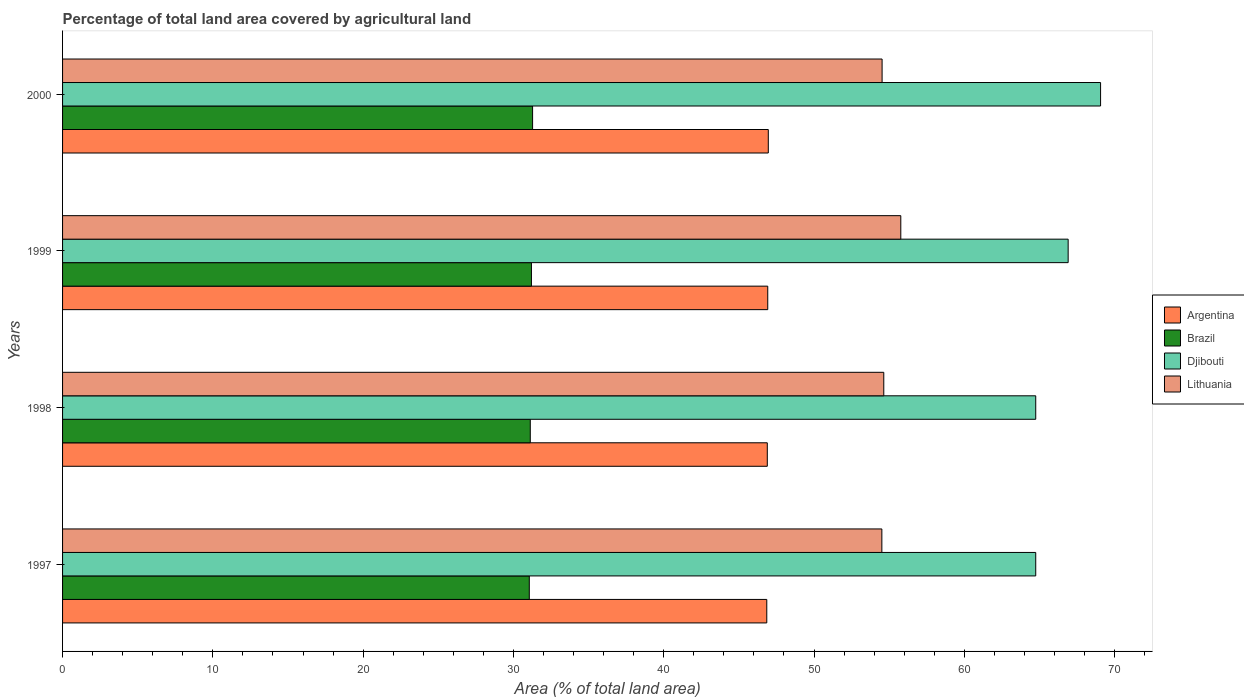How many different coloured bars are there?
Offer a terse response. 4. How many groups of bars are there?
Provide a short and direct response. 4. Are the number of bars on each tick of the Y-axis equal?
Give a very brief answer. Yes. How many bars are there on the 3rd tick from the top?
Provide a succinct answer. 4. How many bars are there on the 2nd tick from the bottom?
Provide a succinct answer. 4. What is the percentage of agricultural land in Lithuania in 1999?
Your answer should be very brief. 55.78. Across all years, what is the maximum percentage of agricultural land in Argentina?
Give a very brief answer. 46.96. Across all years, what is the minimum percentage of agricultural land in Lithuania?
Ensure brevity in your answer.  54.51. In which year was the percentage of agricultural land in Brazil minimum?
Keep it short and to the point. 1997. What is the total percentage of agricultural land in Djibouti in the graph?
Offer a very short reply. 265.49. What is the difference between the percentage of agricultural land in Argentina in 1997 and that in 1998?
Your response must be concise. -0.03. What is the difference between the percentage of agricultural land in Argentina in 2000 and the percentage of agricultural land in Brazil in 1999?
Give a very brief answer. 15.76. What is the average percentage of agricultural land in Djibouti per year?
Provide a short and direct response. 66.37. In the year 1999, what is the difference between the percentage of agricultural land in Argentina and percentage of agricultural land in Brazil?
Offer a very short reply. 15.72. In how many years, is the percentage of agricultural land in Djibouti greater than 44 %?
Keep it short and to the point. 4. What is the ratio of the percentage of agricultural land in Lithuania in 1997 to that in 2000?
Keep it short and to the point. 1. Is the percentage of agricultural land in Argentina in 1998 less than that in 2000?
Make the answer very short. Yes. What is the difference between the highest and the second highest percentage of agricultural land in Brazil?
Provide a succinct answer. 0.08. What is the difference between the highest and the lowest percentage of agricultural land in Brazil?
Provide a short and direct response. 0.22. Is the sum of the percentage of agricultural land in Djibouti in 1997 and 2000 greater than the maximum percentage of agricultural land in Argentina across all years?
Your answer should be compact. Yes. Is it the case that in every year, the sum of the percentage of agricultural land in Brazil and percentage of agricultural land in Djibouti is greater than the sum of percentage of agricultural land in Lithuania and percentage of agricultural land in Argentina?
Your answer should be very brief. Yes. What does the 2nd bar from the top in 2000 represents?
Your answer should be very brief. Djibouti. What does the 3rd bar from the bottom in 1998 represents?
Offer a very short reply. Djibouti. Is it the case that in every year, the sum of the percentage of agricultural land in Brazil and percentage of agricultural land in Argentina is greater than the percentage of agricultural land in Djibouti?
Offer a terse response. Yes. How many bars are there?
Provide a short and direct response. 16. How many years are there in the graph?
Provide a short and direct response. 4. Are the values on the major ticks of X-axis written in scientific E-notation?
Ensure brevity in your answer.  No. Does the graph contain any zero values?
Your answer should be compact. No. Does the graph contain grids?
Ensure brevity in your answer.  No. Where does the legend appear in the graph?
Your answer should be very brief. Center right. How many legend labels are there?
Offer a terse response. 4. How are the legend labels stacked?
Give a very brief answer. Vertical. What is the title of the graph?
Offer a very short reply. Percentage of total land area covered by agricultural land. Does "Virgin Islands" appear as one of the legend labels in the graph?
Ensure brevity in your answer.  No. What is the label or title of the X-axis?
Your answer should be very brief. Area (% of total land area). What is the Area (% of total land area) of Argentina in 1997?
Make the answer very short. 46.86. What is the Area (% of total land area) of Brazil in 1997?
Provide a succinct answer. 31.06. What is the Area (% of total land area) of Djibouti in 1997?
Your answer should be compact. 64.75. What is the Area (% of total land area) in Lithuania in 1997?
Provide a short and direct response. 54.51. What is the Area (% of total land area) in Argentina in 1998?
Your answer should be very brief. 46.89. What is the Area (% of total land area) in Brazil in 1998?
Your response must be concise. 31.12. What is the Area (% of total land area) of Djibouti in 1998?
Your answer should be compact. 64.75. What is the Area (% of total land area) in Lithuania in 1998?
Give a very brief answer. 54.64. What is the Area (% of total land area) in Argentina in 1999?
Provide a short and direct response. 46.92. What is the Area (% of total land area) of Brazil in 1999?
Give a very brief answer. 31.2. What is the Area (% of total land area) of Djibouti in 1999?
Ensure brevity in your answer.  66.91. What is the Area (% of total land area) in Lithuania in 1999?
Offer a terse response. 55.78. What is the Area (% of total land area) in Argentina in 2000?
Your response must be concise. 46.96. What is the Area (% of total land area) of Brazil in 2000?
Provide a succinct answer. 31.28. What is the Area (% of total land area) of Djibouti in 2000?
Ensure brevity in your answer.  69.07. What is the Area (% of total land area) in Lithuania in 2000?
Provide a succinct answer. 54.53. Across all years, what is the maximum Area (% of total land area) in Argentina?
Provide a succinct answer. 46.96. Across all years, what is the maximum Area (% of total land area) in Brazil?
Give a very brief answer. 31.28. Across all years, what is the maximum Area (% of total land area) in Djibouti?
Give a very brief answer. 69.07. Across all years, what is the maximum Area (% of total land area) of Lithuania?
Provide a short and direct response. 55.78. Across all years, what is the minimum Area (% of total land area) of Argentina?
Your answer should be compact. 46.86. Across all years, what is the minimum Area (% of total land area) of Brazil?
Keep it short and to the point. 31.06. Across all years, what is the minimum Area (% of total land area) in Djibouti?
Ensure brevity in your answer.  64.75. Across all years, what is the minimum Area (% of total land area) of Lithuania?
Your answer should be compact. 54.51. What is the total Area (% of total land area) in Argentina in the graph?
Offer a very short reply. 187.63. What is the total Area (% of total land area) of Brazil in the graph?
Offer a very short reply. 124.65. What is the total Area (% of total land area) of Djibouti in the graph?
Your answer should be compact. 265.49. What is the total Area (% of total land area) of Lithuania in the graph?
Your answer should be compact. 219.46. What is the difference between the Area (% of total land area) of Argentina in 1997 and that in 1998?
Your answer should be compact. -0.03. What is the difference between the Area (% of total land area) in Brazil in 1997 and that in 1998?
Make the answer very short. -0.07. What is the difference between the Area (% of total land area) in Djibouti in 1997 and that in 1998?
Provide a succinct answer. 0. What is the difference between the Area (% of total land area) of Lithuania in 1997 and that in 1998?
Your answer should be very brief. -0.13. What is the difference between the Area (% of total land area) of Argentina in 1997 and that in 1999?
Keep it short and to the point. -0.06. What is the difference between the Area (% of total land area) of Brazil in 1997 and that in 1999?
Provide a short and direct response. -0.14. What is the difference between the Area (% of total land area) in Djibouti in 1997 and that in 1999?
Provide a short and direct response. -2.16. What is the difference between the Area (% of total land area) in Lithuania in 1997 and that in 1999?
Offer a terse response. -1.26. What is the difference between the Area (% of total land area) of Argentina in 1997 and that in 2000?
Your answer should be compact. -0.1. What is the difference between the Area (% of total land area) in Brazil in 1997 and that in 2000?
Your response must be concise. -0.22. What is the difference between the Area (% of total land area) in Djibouti in 1997 and that in 2000?
Keep it short and to the point. -4.31. What is the difference between the Area (% of total land area) in Lithuania in 1997 and that in 2000?
Keep it short and to the point. -0.02. What is the difference between the Area (% of total land area) in Argentina in 1998 and that in 1999?
Provide a short and direct response. -0.03. What is the difference between the Area (% of total land area) in Brazil in 1998 and that in 1999?
Keep it short and to the point. -0.08. What is the difference between the Area (% of total land area) in Djibouti in 1998 and that in 1999?
Give a very brief answer. -2.16. What is the difference between the Area (% of total land area) in Lithuania in 1998 and that in 1999?
Keep it short and to the point. -1.13. What is the difference between the Area (% of total land area) of Argentina in 1998 and that in 2000?
Offer a terse response. -0.07. What is the difference between the Area (% of total land area) of Brazil in 1998 and that in 2000?
Provide a succinct answer. -0.15. What is the difference between the Area (% of total land area) in Djibouti in 1998 and that in 2000?
Offer a very short reply. -4.31. What is the difference between the Area (% of total land area) of Lithuania in 1998 and that in 2000?
Your response must be concise. 0.11. What is the difference between the Area (% of total land area) in Argentina in 1999 and that in 2000?
Make the answer very short. -0.04. What is the difference between the Area (% of total land area) in Brazil in 1999 and that in 2000?
Give a very brief answer. -0.08. What is the difference between the Area (% of total land area) of Djibouti in 1999 and that in 2000?
Offer a very short reply. -2.16. What is the difference between the Area (% of total land area) of Lithuania in 1999 and that in 2000?
Give a very brief answer. 1.24. What is the difference between the Area (% of total land area) of Argentina in 1997 and the Area (% of total land area) of Brazil in 1998?
Your answer should be very brief. 15.74. What is the difference between the Area (% of total land area) in Argentina in 1997 and the Area (% of total land area) in Djibouti in 1998?
Your answer should be very brief. -17.9. What is the difference between the Area (% of total land area) in Argentina in 1997 and the Area (% of total land area) in Lithuania in 1998?
Ensure brevity in your answer.  -7.78. What is the difference between the Area (% of total land area) in Brazil in 1997 and the Area (% of total land area) in Djibouti in 1998?
Your answer should be very brief. -33.7. What is the difference between the Area (% of total land area) of Brazil in 1997 and the Area (% of total land area) of Lithuania in 1998?
Offer a very short reply. -23.59. What is the difference between the Area (% of total land area) of Djibouti in 1997 and the Area (% of total land area) of Lithuania in 1998?
Your response must be concise. 10.11. What is the difference between the Area (% of total land area) in Argentina in 1997 and the Area (% of total land area) in Brazil in 1999?
Make the answer very short. 15.66. What is the difference between the Area (% of total land area) of Argentina in 1997 and the Area (% of total land area) of Djibouti in 1999?
Ensure brevity in your answer.  -20.05. What is the difference between the Area (% of total land area) in Argentina in 1997 and the Area (% of total land area) in Lithuania in 1999?
Provide a succinct answer. -8.92. What is the difference between the Area (% of total land area) of Brazil in 1997 and the Area (% of total land area) of Djibouti in 1999?
Your response must be concise. -35.86. What is the difference between the Area (% of total land area) in Brazil in 1997 and the Area (% of total land area) in Lithuania in 1999?
Offer a very short reply. -24.72. What is the difference between the Area (% of total land area) in Djibouti in 1997 and the Area (% of total land area) in Lithuania in 1999?
Your answer should be compact. 8.98. What is the difference between the Area (% of total land area) in Argentina in 1997 and the Area (% of total land area) in Brazil in 2000?
Offer a terse response. 15.58. What is the difference between the Area (% of total land area) in Argentina in 1997 and the Area (% of total land area) in Djibouti in 2000?
Give a very brief answer. -22.21. What is the difference between the Area (% of total land area) in Argentina in 1997 and the Area (% of total land area) in Lithuania in 2000?
Your answer should be compact. -7.67. What is the difference between the Area (% of total land area) in Brazil in 1997 and the Area (% of total land area) in Djibouti in 2000?
Keep it short and to the point. -38.01. What is the difference between the Area (% of total land area) of Brazil in 1997 and the Area (% of total land area) of Lithuania in 2000?
Your answer should be very brief. -23.48. What is the difference between the Area (% of total land area) of Djibouti in 1997 and the Area (% of total land area) of Lithuania in 2000?
Make the answer very short. 10.22. What is the difference between the Area (% of total land area) of Argentina in 1998 and the Area (% of total land area) of Brazil in 1999?
Keep it short and to the point. 15.69. What is the difference between the Area (% of total land area) in Argentina in 1998 and the Area (% of total land area) in Djibouti in 1999?
Your answer should be very brief. -20.02. What is the difference between the Area (% of total land area) in Argentina in 1998 and the Area (% of total land area) in Lithuania in 1999?
Your response must be concise. -8.88. What is the difference between the Area (% of total land area) of Brazil in 1998 and the Area (% of total land area) of Djibouti in 1999?
Your response must be concise. -35.79. What is the difference between the Area (% of total land area) of Brazil in 1998 and the Area (% of total land area) of Lithuania in 1999?
Your answer should be compact. -24.65. What is the difference between the Area (% of total land area) in Djibouti in 1998 and the Area (% of total land area) in Lithuania in 1999?
Keep it short and to the point. 8.98. What is the difference between the Area (% of total land area) of Argentina in 1998 and the Area (% of total land area) of Brazil in 2000?
Provide a succinct answer. 15.62. What is the difference between the Area (% of total land area) of Argentina in 1998 and the Area (% of total land area) of Djibouti in 2000?
Keep it short and to the point. -22.18. What is the difference between the Area (% of total land area) of Argentina in 1998 and the Area (% of total land area) of Lithuania in 2000?
Keep it short and to the point. -7.64. What is the difference between the Area (% of total land area) of Brazil in 1998 and the Area (% of total land area) of Djibouti in 2000?
Your response must be concise. -37.95. What is the difference between the Area (% of total land area) in Brazil in 1998 and the Area (% of total land area) in Lithuania in 2000?
Your answer should be compact. -23.41. What is the difference between the Area (% of total land area) in Djibouti in 1998 and the Area (% of total land area) in Lithuania in 2000?
Your answer should be very brief. 10.22. What is the difference between the Area (% of total land area) of Argentina in 1999 and the Area (% of total land area) of Brazil in 2000?
Your answer should be compact. 15.65. What is the difference between the Area (% of total land area) in Argentina in 1999 and the Area (% of total land area) in Djibouti in 2000?
Keep it short and to the point. -22.15. What is the difference between the Area (% of total land area) in Argentina in 1999 and the Area (% of total land area) in Lithuania in 2000?
Offer a terse response. -7.61. What is the difference between the Area (% of total land area) of Brazil in 1999 and the Area (% of total land area) of Djibouti in 2000?
Offer a terse response. -37.87. What is the difference between the Area (% of total land area) in Brazil in 1999 and the Area (% of total land area) in Lithuania in 2000?
Make the answer very short. -23.33. What is the difference between the Area (% of total land area) of Djibouti in 1999 and the Area (% of total land area) of Lithuania in 2000?
Give a very brief answer. 12.38. What is the average Area (% of total land area) in Argentina per year?
Offer a very short reply. 46.91. What is the average Area (% of total land area) of Brazil per year?
Ensure brevity in your answer.  31.16. What is the average Area (% of total land area) in Djibouti per year?
Keep it short and to the point. 66.37. What is the average Area (% of total land area) in Lithuania per year?
Give a very brief answer. 54.87. In the year 1997, what is the difference between the Area (% of total land area) in Argentina and Area (% of total land area) in Brazil?
Ensure brevity in your answer.  15.8. In the year 1997, what is the difference between the Area (% of total land area) of Argentina and Area (% of total land area) of Djibouti?
Your answer should be very brief. -17.9. In the year 1997, what is the difference between the Area (% of total land area) of Argentina and Area (% of total land area) of Lithuania?
Your answer should be very brief. -7.66. In the year 1997, what is the difference between the Area (% of total land area) in Brazil and Area (% of total land area) in Djibouti?
Your answer should be compact. -33.7. In the year 1997, what is the difference between the Area (% of total land area) in Brazil and Area (% of total land area) in Lithuania?
Offer a terse response. -23.46. In the year 1997, what is the difference between the Area (% of total land area) of Djibouti and Area (% of total land area) of Lithuania?
Your response must be concise. 10.24. In the year 1998, what is the difference between the Area (% of total land area) in Argentina and Area (% of total land area) in Brazil?
Offer a very short reply. 15.77. In the year 1998, what is the difference between the Area (% of total land area) of Argentina and Area (% of total land area) of Djibouti?
Make the answer very short. -17.86. In the year 1998, what is the difference between the Area (% of total land area) in Argentina and Area (% of total land area) in Lithuania?
Your answer should be compact. -7.75. In the year 1998, what is the difference between the Area (% of total land area) of Brazil and Area (% of total land area) of Djibouti?
Make the answer very short. -33.63. In the year 1998, what is the difference between the Area (% of total land area) in Brazil and Area (% of total land area) in Lithuania?
Offer a very short reply. -23.52. In the year 1998, what is the difference between the Area (% of total land area) of Djibouti and Area (% of total land area) of Lithuania?
Ensure brevity in your answer.  10.11. In the year 1999, what is the difference between the Area (% of total land area) of Argentina and Area (% of total land area) of Brazil?
Offer a terse response. 15.72. In the year 1999, what is the difference between the Area (% of total land area) in Argentina and Area (% of total land area) in Djibouti?
Your response must be concise. -19.99. In the year 1999, what is the difference between the Area (% of total land area) in Argentina and Area (% of total land area) in Lithuania?
Offer a very short reply. -8.85. In the year 1999, what is the difference between the Area (% of total land area) in Brazil and Area (% of total land area) in Djibouti?
Ensure brevity in your answer.  -35.71. In the year 1999, what is the difference between the Area (% of total land area) in Brazil and Area (% of total land area) in Lithuania?
Provide a succinct answer. -24.58. In the year 1999, what is the difference between the Area (% of total land area) of Djibouti and Area (% of total land area) of Lithuania?
Your response must be concise. 11.14. In the year 2000, what is the difference between the Area (% of total land area) in Argentina and Area (% of total land area) in Brazil?
Your answer should be very brief. 15.68. In the year 2000, what is the difference between the Area (% of total land area) of Argentina and Area (% of total land area) of Djibouti?
Your answer should be compact. -22.11. In the year 2000, what is the difference between the Area (% of total land area) of Argentina and Area (% of total land area) of Lithuania?
Give a very brief answer. -7.57. In the year 2000, what is the difference between the Area (% of total land area) in Brazil and Area (% of total land area) in Djibouti?
Ensure brevity in your answer.  -37.79. In the year 2000, what is the difference between the Area (% of total land area) of Brazil and Area (% of total land area) of Lithuania?
Your answer should be very brief. -23.26. In the year 2000, what is the difference between the Area (% of total land area) of Djibouti and Area (% of total land area) of Lithuania?
Your answer should be very brief. 14.54. What is the ratio of the Area (% of total land area) of Brazil in 1997 to that in 1998?
Offer a very short reply. 1. What is the ratio of the Area (% of total land area) in Lithuania in 1997 to that in 1998?
Make the answer very short. 1. What is the ratio of the Area (% of total land area) in Argentina in 1997 to that in 1999?
Your response must be concise. 1. What is the ratio of the Area (% of total land area) of Djibouti in 1997 to that in 1999?
Offer a very short reply. 0.97. What is the ratio of the Area (% of total land area) of Lithuania in 1997 to that in 1999?
Provide a short and direct response. 0.98. What is the ratio of the Area (% of total land area) in Brazil in 1998 to that in 1999?
Your answer should be very brief. 1. What is the ratio of the Area (% of total land area) in Djibouti in 1998 to that in 1999?
Make the answer very short. 0.97. What is the ratio of the Area (% of total land area) in Lithuania in 1998 to that in 1999?
Your answer should be very brief. 0.98. What is the ratio of the Area (% of total land area) of Brazil in 1998 to that in 2000?
Ensure brevity in your answer.  0.99. What is the ratio of the Area (% of total land area) of Djibouti in 1998 to that in 2000?
Your answer should be compact. 0.94. What is the ratio of the Area (% of total land area) in Brazil in 1999 to that in 2000?
Your answer should be compact. 1. What is the ratio of the Area (% of total land area) of Djibouti in 1999 to that in 2000?
Provide a succinct answer. 0.97. What is the ratio of the Area (% of total land area) of Lithuania in 1999 to that in 2000?
Your response must be concise. 1.02. What is the difference between the highest and the second highest Area (% of total land area) of Argentina?
Keep it short and to the point. 0.04. What is the difference between the highest and the second highest Area (% of total land area) of Brazil?
Give a very brief answer. 0.08. What is the difference between the highest and the second highest Area (% of total land area) of Djibouti?
Provide a succinct answer. 2.16. What is the difference between the highest and the second highest Area (% of total land area) of Lithuania?
Ensure brevity in your answer.  1.13. What is the difference between the highest and the lowest Area (% of total land area) of Argentina?
Provide a short and direct response. 0.1. What is the difference between the highest and the lowest Area (% of total land area) of Brazil?
Your response must be concise. 0.22. What is the difference between the highest and the lowest Area (% of total land area) of Djibouti?
Give a very brief answer. 4.31. What is the difference between the highest and the lowest Area (% of total land area) of Lithuania?
Your answer should be very brief. 1.26. 